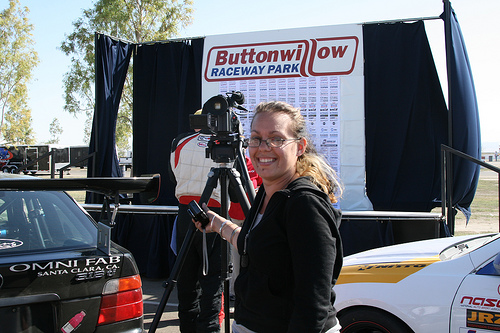<image>
Is there a vehicle behind the woman? No. The vehicle is not behind the woman. From this viewpoint, the vehicle appears to be positioned elsewhere in the scene. Where is the sign in relation to the man? Is it above the man? No. The sign is not positioned above the man. The vertical arrangement shows a different relationship. 